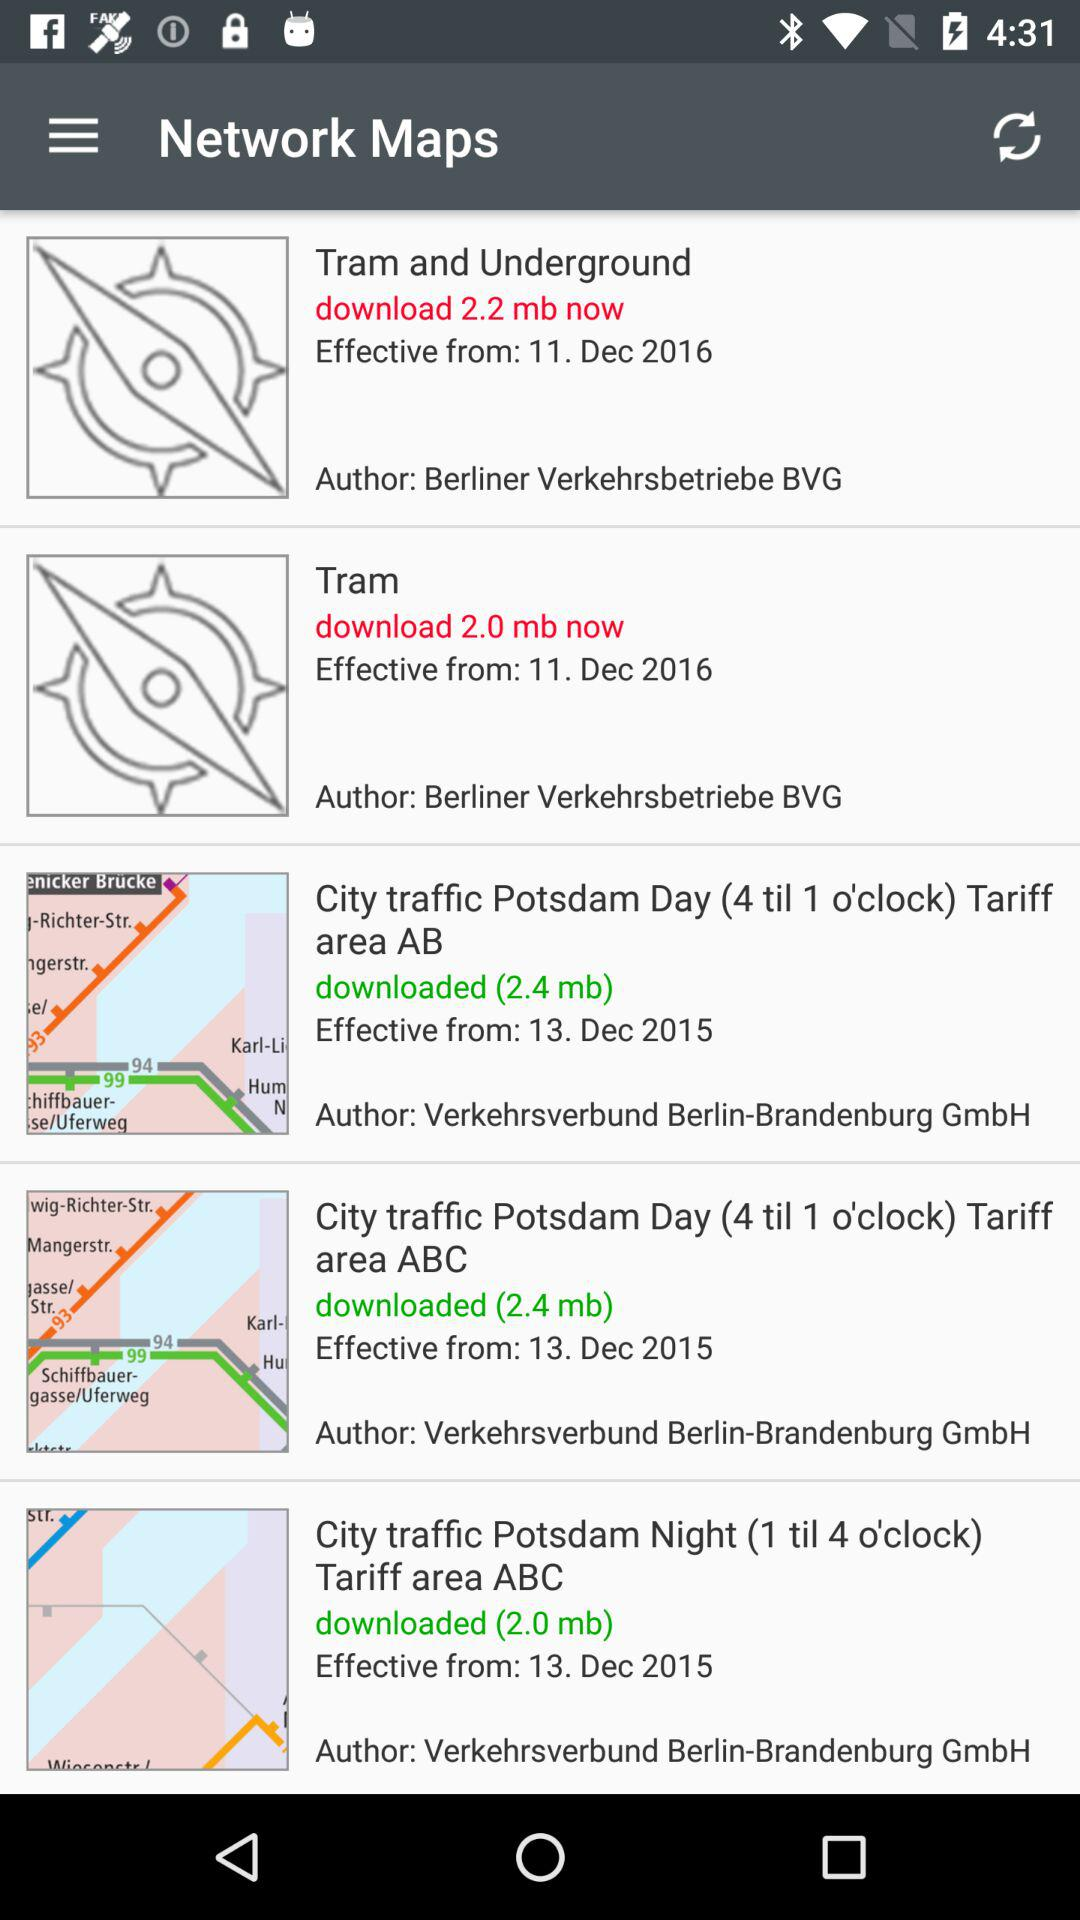What is the Tram network map file memory requirement?
When the provided information is insufficient, respond with <no answer>. <no answer> 